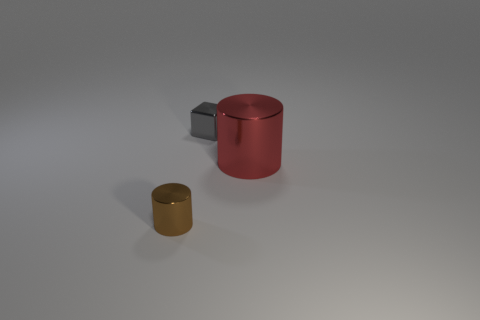Add 2 tiny cylinders. How many objects exist? 5 Subtract all blocks. How many objects are left? 2 Add 1 big gray metallic things. How many big gray metallic things exist? 1 Subtract 0 green balls. How many objects are left? 3 Subtract all brown cylinders. Subtract all large gray matte objects. How many objects are left? 2 Add 3 large red metallic things. How many large red metallic things are left? 4 